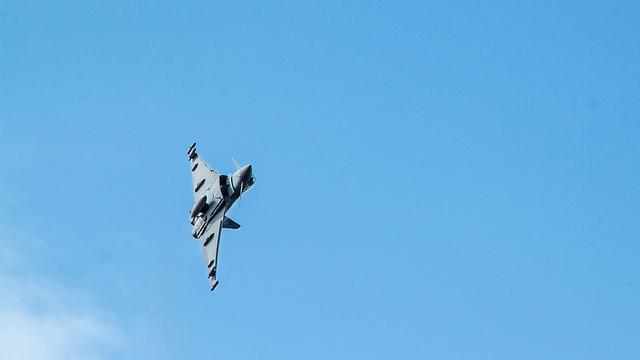Where activity is taking place?
Keep it brief. Flying. Are there any clouds in the sky?
Answer briefly. Yes. Could this plane be military?
Quick response, please. Yes. Is this going faster than a car?
Give a very brief answer. Yes. Is it possible to tell if the plane is flying parallel to the horizon?
Quick response, please. No. 